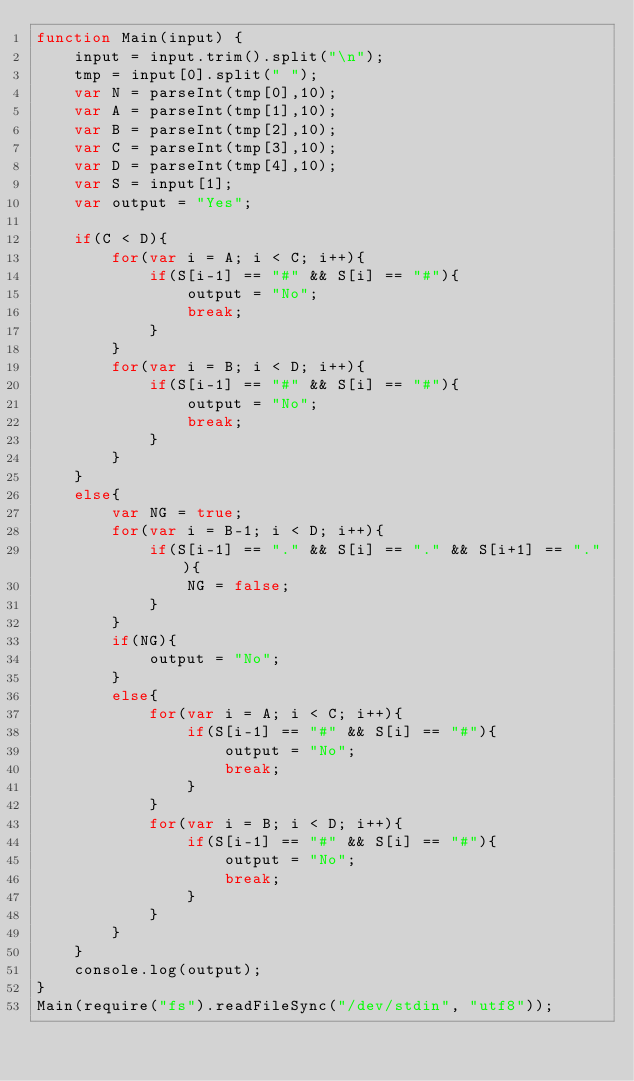<code> <loc_0><loc_0><loc_500><loc_500><_JavaScript_>function Main(input) {
    input = input.trim().split("\n");
    tmp = input[0].split(" ");
    var N = parseInt(tmp[0],10);
    var A = parseInt(tmp[1],10);
    var B = parseInt(tmp[2],10);
    var C = parseInt(tmp[3],10);
    var D = parseInt(tmp[4],10);
    var S = input[1];
    var output = "Yes";

    if(C < D){
        for(var i = A; i < C; i++){
            if(S[i-1] == "#" && S[i] == "#"){
                output = "No";
                break;
            }
        }
        for(var i = B; i < D; i++){
            if(S[i-1] == "#" && S[i] == "#"){
                output = "No";
                break;
            }
        }
    }
    else{
        var NG = true;
        for(var i = B-1; i < D; i++){
            if(S[i-1] == "." && S[i] == "." && S[i+1] == "."){
                NG = false;
            }
        }
        if(NG){
            output = "No";
        }
        else{
            for(var i = A; i < C; i++){
                if(S[i-1] == "#" && S[i] == "#"){
                    output = "No";
                    break;
                }
            }
            for(var i = B; i < D; i++){
                if(S[i-1] == "#" && S[i] == "#"){
                    output = "No";
                    break;
                }
            }
        }
    }
    console.log(output);
}
Main(require("fs").readFileSync("/dev/stdin", "utf8"));</code> 